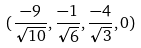Convert formula to latex. <formula><loc_0><loc_0><loc_500><loc_500>( \frac { - 9 } { \sqrt { 1 0 } } , \frac { - 1 } { \sqrt { 6 } } , \frac { - 4 } { \sqrt { 3 } } , 0 )</formula> 